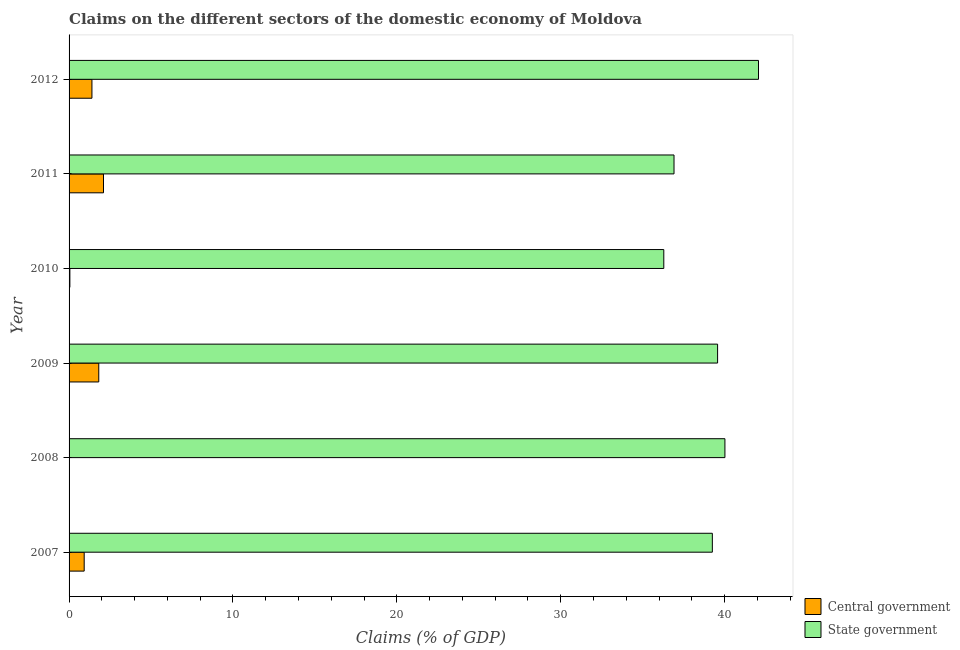How many bars are there on the 2nd tick from the top?
Provide a succinct answer. 2. What is the label of the 5th group of bars from the top?
Offer a very short reply. 2008. In how many cases, is the number of bars for a given year not equal to the number of legend labels?
Your answer should be very brief. 1. Across all years, what is the maximum claims on central government?
Offer a terse response. 2.1. Across all years, what is the minimum claims on state government?
Provide a short and direct response. 36.29. In which year was the claims on state government maximum?
Give a very brief answer. 2012. What is the total claims on state government in the graph?
Keep it short and to the point. 234.09. What is the difference between the claims on central government in 2009 and that in 2011?
Make the answer very short. -0.29. What is the difference between the claims on state government in 2008 and the claims on central government in 2007?
Provide a short and direct response. 39.09. What is the average claims on state government per year?
Make the answer very short. 39.02. In the year 2011, what is the difference between the claims on central government and claims on state government?
Your answer should be compact. -34.81. What is the ratio of the claims on central government in 2011 to that in 2012?
Make the answer very short. 1.51. Is the claims on central government in 2007 less than that in 2012?
Make the answer very short. Yes. Is the difference between the claims on central government in 2010 and 2011 greater than the difference between the claims on state government in 2010 and 2011?
Keep it short and to the point. No. What is the difference between the highest and the second highest claims on state government?
Give a very brief answer. 2.05. What is the difference between the highest and the lowest claims on central government?
Offer a very short reply. 2.1. Is the sum of the claims on state government in 2010 and 2011 greater than the maximum claims on central government across all years?
Make the answer very short. Yes. What is the difference between two consecutive major ticks on the X-axis?
Make the answer very short. 10. Where does the legend appear in the graph?
Your response must be concise. Bottom right. What is the title of the graph?
Your answer should be compact. Claims on the different sectors of the domestic economy of Moldova. What is the label or title of the X-axis?
Keep it short and to the point. Claims (% of GDP). What is the label or title of the Y-axis?
Provide a short and direct response. Year. What is the Claims (% of GDP) of Central government in 2007?
Give a very brief answer. 0.92. What is the Claims (% of GDP) of State government in 2007?
Your answer should be compact. 39.25. What is the Claims (% of GDP) of Central government in 2008?
Offer a terse response. 0. What is the Claims (% of GDP) in State government in 2008?
Offer a very short reply. 40.02. What is the Claims (% of GDP) in Central government in 2009?
Give a very brief answer. 1.81. What is the Claims (% of GDP) in State government in 2009?
Your response must be concise. 39.57. What is the Claims (% of GDP) in Central government in 2010?
Give a very brief answer. 0.05. What is the Claims (% of GDP) in State government in 2010?
Make the answer very short. 36.29. What is the Claims (% of GDP) in Central government in 2011?
Offer a terse response. 2.1. What is the Claims (% of GDP) in State government in 2011?
Provide a succinct answer. 36.91. What is the Claims (% of GDP) in Central government in 2012?
Provide a short and direct response. 1.39. What is the Claims (% of GDP) of State government in 2012?
Ensure brevity in your answer.  42.06. Across all years, what is the maximum Claims (% of GDP) of Central government?
Your answer should be compact. 2.1. Across all years, what is the maximum Claims (% of GDP) in State government?
Provide a succinct answer. 42.06. Across all years, what is the minimum Claims (% of GDP) of Central government?
Your answer should be very brief. 0. Across all years, what is the minimum Claims (% of GDP) of State government?
Make the answer very short. 36.29. What is the total Claims (% of GDP) in Central government in the graph?
Your response must be concise. 6.28. What is the total Claims (% of GDP) of State government in the graph?
Your answer should be very brief. 234.09. What is the difference between the Claims (% of GDP) of State government in 2007 and that in 2008?
Provide a short and direct response. -0.77. What is the difference between the Claims (% of GDP) of Central government in 2007 and that in 2009?
Make the answer very short. -0.89. What is the difference between the Claims (% of GDP) of State government in 2007 and that in 2009?
Keep it short and to the point. -0.32. What is the difference between the Claims (% of GDP) of Central government in 2007 and that in 2010?
Offer a very short reply. 0.87. What is the difference between the Claims (% of GDP) in State government in 2007 and that in 2010?
Ensure brevity in your answer.  2.96. What is the difference between the Claims (% of GDP) of Central government in 2007 and that in 2011?
Your response must be concise. -1.18. What is the difference between the Claims (% of GDP) of State government in 2007 and that in 2011?
Ensure brevity in your answer.  2.34. What is the difference between the Claims (% of GDP) in Central government in 2007 and that in 2012?
Provide a succinct answer. -0.47. What is the difference between the Claims (% of GDP) of State government in 2007 and that in 2012?
Your response must be concise. -2.82. What is the difference between the Claims (% of GDP) of State government in 2008 and that in 2009?
Your answer should be very brief. 0.45. What is the difference between the Claims (% of GDP) in State government in 2008 and that in 2010?
Provide a succinct answer. 3.73. What is the difference between the Claims (% of GDP) in State government in 2008 and that in 2011?
Provide a short and direct response. 3.11. What is the difference between the Claims (% of GDP) in State government in 2008 and that in 2012?
Your answer should be very brief. -2.05. What is the difference between the Claims (% of GDP) of Central government in 2009 and that in 2010?
Make the answer very short. 1.76. What is the difference between the Claims (% of GDP) of State government in 2009 and that in 2010?
Provide a succinct answer. 3.28. What is the difference between the Claims (% of GDP) in Central government in 2009 and that in 2011?
Provide a succinct answer. -0.29. What is the difference between the Claims (% of GDP) of State government in 2009 and that in 2011?
Offer a terse response. 2.66. What is the difference between the Claims (% of GDP) of Central government in 2009 and that in 2012?
Provide a succinct answer. 0.42. What is the difference between the Claims (% of GDP) of State government in 2009 and that in 2012?
Make the answer very short. -2.5. What is the difference between the Claims (% of GDP) of Central government in 2010 and that in 2011?
Offer a very short reply. -2.05. What is the difference between the Claims (% of GDP) in State government in 2010 and that in 2011?
Provide a short and direct response. -0.62. What is the difference between the Claims (% of GDP) in Central government in 2010 and that in 2012?
Ensure brevity in your answer.  -1.35. What is the difference between the Claims (% of GDP) of State government in 2010 and that in 2012?
Provide a short and direct response. -5.78. What is the difference between the Claims (% of GDP) in Central government in 2011 and that in 2012?
Provide a short and direct response. 0.71. What is the difference between the Claims (% of GDP) in State government in 2011 and that in 2012?
Make the answer very short. -5.15. What is the difference between the Claims (% of GDP) of Central government in 2007 and the Claims (% of GDP) of State government in 2008?
Give a very brief answer. -39.09. What is the difference between the Claims (% of GDP) in Central government in 2007 and the Claims (% of GDP) in State government in 2009?
Offer a terse response. -38.65. What is the difference between the Claims (% of GDP) in Central government in 2007 and the Claims (% of GDP) in State government in 2010?
Ensure brevity in your answer.  -35.36. What is the difference between the Claims (% of GDP) of Central government in 2007 and the Claims (% of GDP) of State government in 2011?
Offer a very short reply. -35.99. What is the difference between the Claims (% of GDP) of Central government in 2007 and the Claims (% of GDP) of State government in 2012?
Offer a very short reply. -41.14. What is the difference between the Claims (% of GDP) in Central government in 2009 and the Claims (% of GDP) in State government in 2010?
Ensure brevity in your answer.  -34.48. What is the difference between the Claims (% of GDP) of Central government in 2009 and the Claims (% of GDP) of State government in 2011?
Make the answer very short. -35.1. What is the difference between the Claims (% of GDP) of Central government in 2009 and the Claims (% of GDP) of State government in 2012?
Give a very brief answer. -40.25. What is the difference between the Claims (% of GDP) in Central government in 2010 and the Claims (% of GDP) in State government in 2011?
Offer a very short reply. -36.86. What is the difference between the Claims (% of GDP) of Central government in 2010 and the Claims (% of GDP) of State government in 2012?
Your answer should be compact. -42.02. What is the difference between the Claims (% of GDP) of Central government in 2011 and the Claims (% of GDP) of State government in 2012?
Offer a very short reply. -39.96. What is the average Claims (% of GDP) in Central government per year?
Give a very brief answer. 1.05. What is the average Claims (% of GDP) in State government per year?
Ensure brevity in your answer.  39.02. In the year 2007, what is the difference between the Claims (% of GDP) in Central government and Claims (% of GDP) in State government?
Your response must be concise. -38.33. In the year 2009, what is the difference between the Claims (% of GDP) of Central government and Claims (% of GDP) of State government?
Keep it short and to the point. -37.76. In the year 2010, what is the difference between the Claims (% of GDP) of Central government and Claims (% of GDP) of State government?
Your response must be concise. -36.24. In the year 2011, what is the difference between the Claims (% of GDP) in Central government and Claims (% of GDP) in State government?
Give a very brief answer. -34.81. In the year 2012, what is the difference between the Claims (% of GDP) of Central government and Claims (% of GDP) of State government?
Ensure brevity in your answer.  -40.67. What is the ratio of the Claims (% of GDP) in State government in 2007 to that in 2008?
Your answer should be compact. 0.98. What is the ratio of the Claims (% of GDP) in Central government in 2007 to that in 2009?
Your answer should be compact. 0.51. What is the ratio of the Claims (% of GDP) of State government in 2007 to that in 2009?
Provide a short and direct response. 0.99. What is the ratio of the Claims (% of GDP) of Central government in 2007 to that in 2010?
Make the answer very short. 18.7. What is the ratio of the Claims (% of GDP) in State government in 2007 to that in 2010?
Provide a succinct answer. 1.08. What is the ratio of the Claims (% of GDP) of Central government in 2007 to that in 2011?
Make the answer very short. 0.44. What is the ratio of the Claims (% of GDP) of State government in 2007 to that in 2011?
Ensure brevity in your answer.  1.06. What is the ratio of the Claims (% of GDP) in Central government in 2007 to that in 2012?
Your answer should be very brief. 0.66. What is the ratio of the Claims (% of GDP) of State government in 2007 to that in 2012?
Your answer should be very brief. 0.93. What is the ratio of the Claims (% of GDP) in State government in 2008 to that in 2009?
Your answer should be very brief. 1.01. What is the ratio of the Claims (% of GDP) of State government in 2008 to that in 2010?
Offer a very short reply. 1.1. What is the ratio of the Claims (% of GDP) in State government in 2008 to that in 2011?
Offer a terse response. 1.08. What is the ratio of the Claims (% of GDP) in State government in 2008 to that in 2012?
Provide a succinct answer. 0.95. What is the ratio of the Claims (% of GDP) in Central government in 2009 to that in 2010?
Ensure brevity in your answer.  36.74. What is the ratio of the Claims (% of GDP) in State government in 2009 to that in 2010?
Your answer should be compact. 1.09. What is the ratio of the Claims (% of GDP) of Central government in 2009 to that in 2011?
Make the answer very short. 0.86. What is the ratio of the Claims (% of GDP) of State government in 2009 to that in 2011?
Provide a succinct answer. 1.07. What is the ratio of the Claims (% of GDP) of Central government in 2009 to that in 2012?
Give a very brief answer. 1.3. What is the ratio of the Claims (% of GDP) in State government in 2009 to that in 2012?
Provide a succinct answer. 0.94. What is the ratio of the Claims (% of GDP) of Central government in 2010 to that in 2011?
Offer a very short reply. 0.02. What is the ratio of the Claims (% of GDP) of State government in 2010 to that in 2011?
Your answer should be compact. 0.98. What is the ratio of the Claims (% of GDP) of Central government in 2010 to that in 2012?
Provide a succinct answer. 0.04. What is the ratio of the Claims (% of GDP) of State government in 2010 to that in 2012?
Ensure brevity in your answer.  0.86. What is the ratio of the Claims (% of GDP) of Central government in 2011 to that in 2012?
Your answer should be compact. 1.51. What is the ratio of the Claims (% of GDP) of State government in 2011 to that in 2012?
Give a very brief answer. 0.88. What is the difference between the highest and the second highest Claims (% of GDP) of Central government?
Give a very brief answer. 0.29. What is the difference between the highest and the second highest Claims (% of GDP) of State government?
Ensure brevity in your answer.  2.05. What is the difference between the highest and the lowest Claims (% of GDP) in Central government?
Your answer should be very brief. 2.1. What is the difference between the highest and the lowest Claims (% of GDP) of State government?
Your answer should be compact. 5.78. 